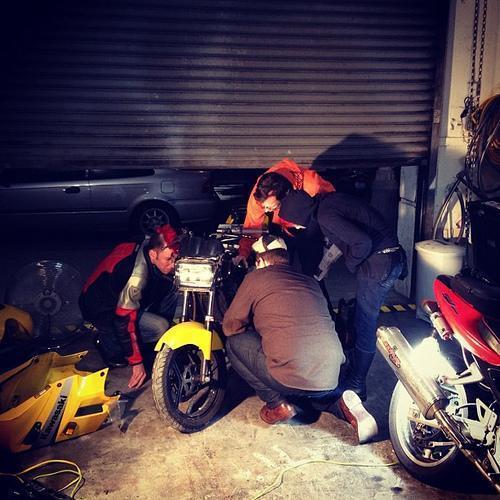How many men are wearing orange?
Give a very brief answer. 1. 